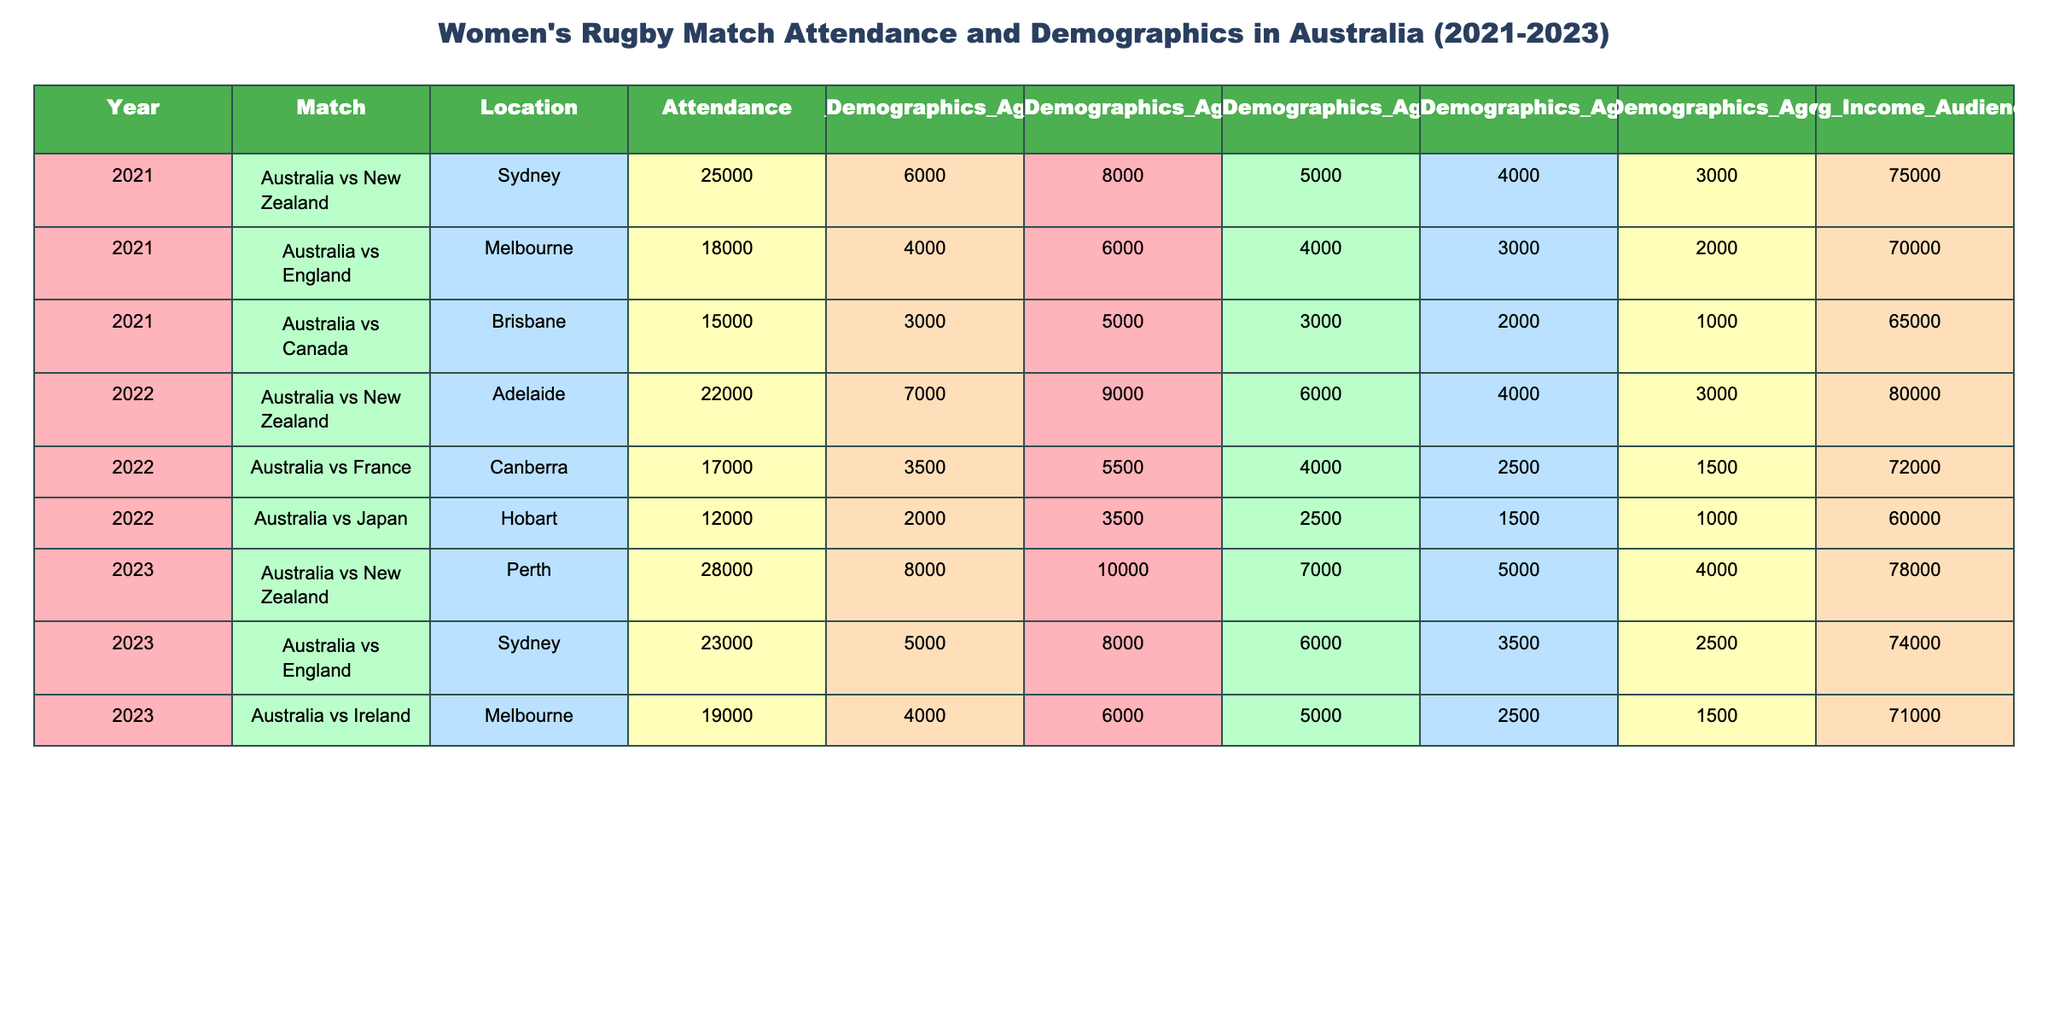What was the highest attendance recorded in the table? The highest attendance is found by observing the 'Attendance' column. The maximum value listed is 28000, recorded during the match Australia vs New Zealand in Perth in 2023.
Answer: 28000 Which city hosted the match with the lowest attendance? To find the lowest attendance, we look for the minimum value in the 'Attendance' column. The match in Hobart against Japan in 2022 had the lowest attendance of 12000.
Answer: Hobart What is the average attendance for the matches held in 2022? To calculate the average, we sum the attendance for all matches in the year 2022: 22000 + 17000 + 12000 = 51000. Dividing by the number of matches (3) gives 51000 / 3 = 17000.
Answer: 17000 Is there any match that had more attendees than 20000 in 2021? We check the 'Attendance' column for 2021, which has values 25000, 18000, and 15000. Only the match Australia vs New Zealand had an attendance of 25000, which is more than 20000.
Answer: Yes What is the total attendance across all matches in 2023? We sum the attendances for all matches in 2023: 28000 + 23000 + 19000 = 70000. Therefore, combining these sums gives us a total of 70000 for 2023.
Answer: 70000 Which age group had the highest representation at the Australia vs England match in Sydney in 2023? We check the 'Gender_Demographics_Age' columns for the Australia vs England match in 2023. The counts are 5000 for Age 18-24, 8000 for Age 25-34, 6000 for Age 35-44, 3500 for Age 45-54, and 2500 for Age 55+. The highest is 8000 for the Age 25-34 group.
Answer: Age 25-34 How did average income of the audience change from 2021 to 2023? We compare the average incomes provided: 2021 has 75000 and 2023 has 78000. The change in average income is calculated as 78000 - 75000 = 3000, indicating an increase.
Answer: Increased by 3000 What percentage of the total attendance for 2022 was represented by female attendees aged 35-44? The total attendance for 2022 is 51000 (sum of 22000, 17000, and 12000). The total female attendees aged 35-44 across the matches are 6000 + 4000 + 2500 = 12500. The percentage is (12500 / 51000) * 100, approximately 24.51%.
Answer: Approximately 24.51% Which match in 2021 had a higher percentage of attendees aged 18-24 compared to others? To find the percentage of attendees aged 18-24 for each match in 2021, we calculate: (Gender_Demographics_Age_18_24 / Attendance) * 100. Australia vs New Zealand: (6000/25000)*100=24%, Australia vs England: (4000/18000)*100=22.22%, Australia vs Canada: (3000/15000)*100=20%. Australia vs New Zealand had the highest percentage of 24%.
Answer: Australia vs New Zealand Did the match locations in 2022 have a more varied demographic representation compared to 2021? We examine the demographic data across each match for 2021 and 2022. In 2021, attendance demographics were more concentrated while 2022 matches show a slightly more balanced distribution across age groups and attendance numbers. Therefore, analysis indicates a slight increase in demographic variance in 2022.
Answer: Yes 